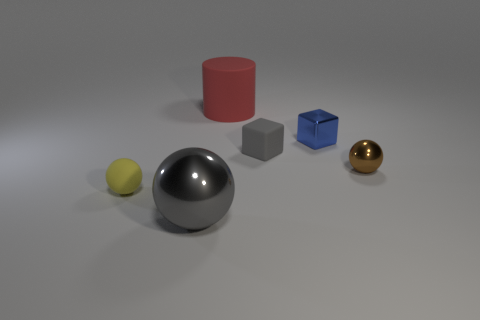Add 4 large green matte cylinders. How many objects exist? 10 Subtract all big gray metallic balls. How many balls are left? 2 Subtract all blue cubes. How many cubes are left? 1 Subtract all blocks. How many objects are left? 4 Subtract 1 cubes. How many cubes are left? 1 Add 4 small yellow matte things. How many small yellow matte things are left? 5 Add 4 gray rubber things. How many gray rubber things exist? 5 Subtract 0 blue spheres. How many objects are left? 6 Subtract all cyan blocks. Subtract all green balls. How many blocks are left? 2 Subtract all cyan cylinders. How many gray cubes are left? 1 